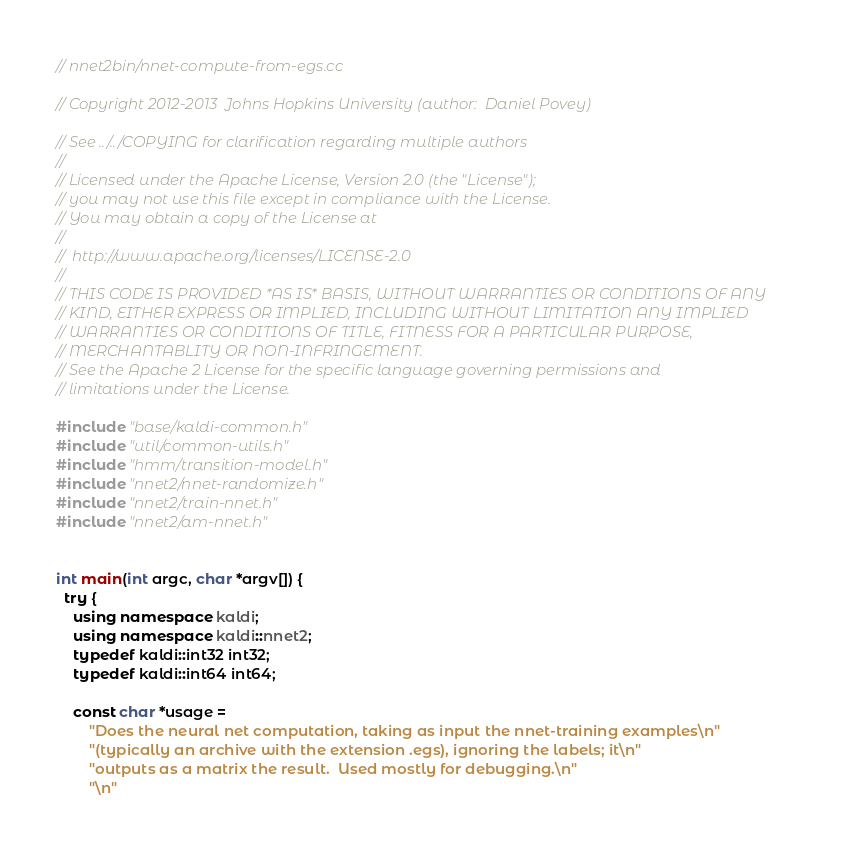Convert code to text. <code><loc_0><loc_0><loc_500><loc_500><_C++_>// nnet2bin/nnet-compute-from-egs.cc

// Copyright 2012-2013  Johns Hopkins University (author:  Daniel Povey)

// See ../../COPYING for clarification regarding multiple authors
//
// Licensed under the Apache License, Version 2.0 (the "License");
// you may not use this file except in compliance with the License.
// You may obtain a copy of the License at
//
//  http://www.apache.org/licenses/LICENSE-2.0
//
// THIS CODE IS PROVIDED *AS IS* BASIS, WITHOUT WARRANTIES OR CONDITIONS OF ANY
// KIND, EITHER EXPRESS OR IMPLIED, INCLUDING WITHOUT LIMITATION ANY IMPLIED
// WARRANTIES OR CONDITIONS OF TITLE, FITNESS FOR A PARTICULAR PURPOSE,
// MERCHANTABLITY OR NON-INFRINGEMENT.
// See the Apache 2 License for the specific language governing permissions and
// limitations under the License.

#include "base/kaldi-common.h"
#include "util/common-utils.h"
#include "hmm/transition-model.h"
#include "nnet2/nnet-randomize.h"
#include "nnet2/train-nnet.h"
#include "nnet2/am-nnet.h"


int main(int argc, char *argv[]) {
  try {
    using namespace kaldi;
    using namespace kaldi::nnet2;
    typedef kaldi::int32 int32;
    typedef kaldi::int64 int64;

    const char *usage =
        "Does the neural net computation, taking as input the nnet-training examples\n"
        "(typically an archive with the extension .egs), ignoring the labels; it\n"
        "outputs as a matrix the result.  Used mostly for debugging.\n"
        "\n"</code> 